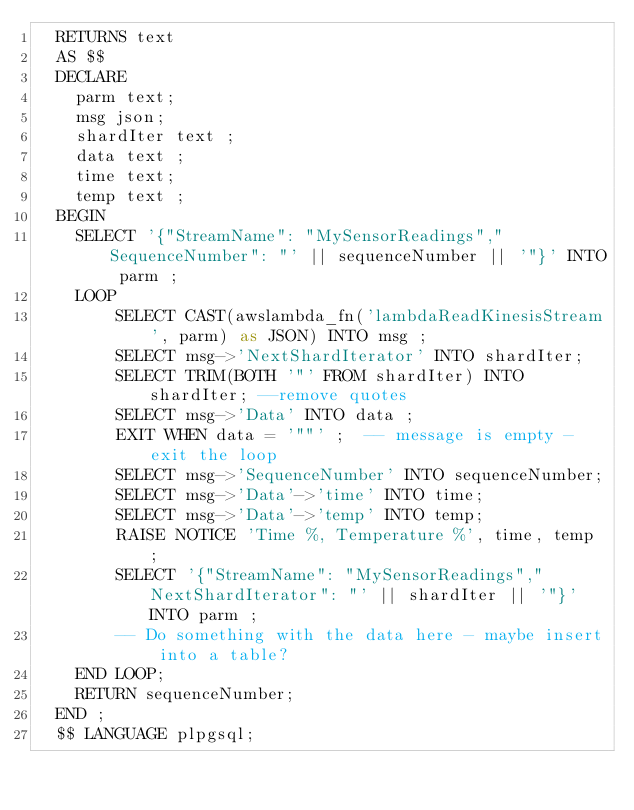Convert code to text. <code><loc_0><loc_0><loc_500><loc_500><_SQL_> 	RETURNS text
 	AS $$
 	DECLARE
 	  parm text;
 	  msg json;
 	  shardIter text ;
 	  data text ;
 	  time text;
 	  temp text ;
 	BEGIN
 	  SELECT '{"StreamName": "MySensorReadings","SequenceNumber": "' || sequenceNumber || '"}' INTO parm ;
 	  LOOP
 	      SELECT CAST(awslambda_fn('lambdaReadKinesisStream', parm) as JSON) INTO msg ;
 	      SELECT msg->'NextShardIterator' INTO shardIter;
 	      SELECT TRIM(BOTH '"' FROM shardIter) INTO shardIter; --remove quotes
 	      SELECT msg->'Data' INTO data ;
 	      EXIT WHEN data = '""' ;  -- message is empty - exit the loop
 	      SELECT msg->'SequenceNumber' INTO sequenceNumber;
 	      SELECT msg->'Data'->'time' INTO time;
 	      SELECT msg->'Data'->'temp' INTO temp;
 	      RAISE NOTICE 'Time %, Temperature %', time, temp ;
 	      SELECT '{"StreamName": "MySensorReadings","NextShardIterator": "' || shardIter || '"}' INTO parm ;
 	      -- Do something with the data here - maybe insert into a table?
 	  END LOOP;
 	  RETURN sequenceNumber;
 	END ;
 	$$ LANGUAGE plpgsql;
</code> 